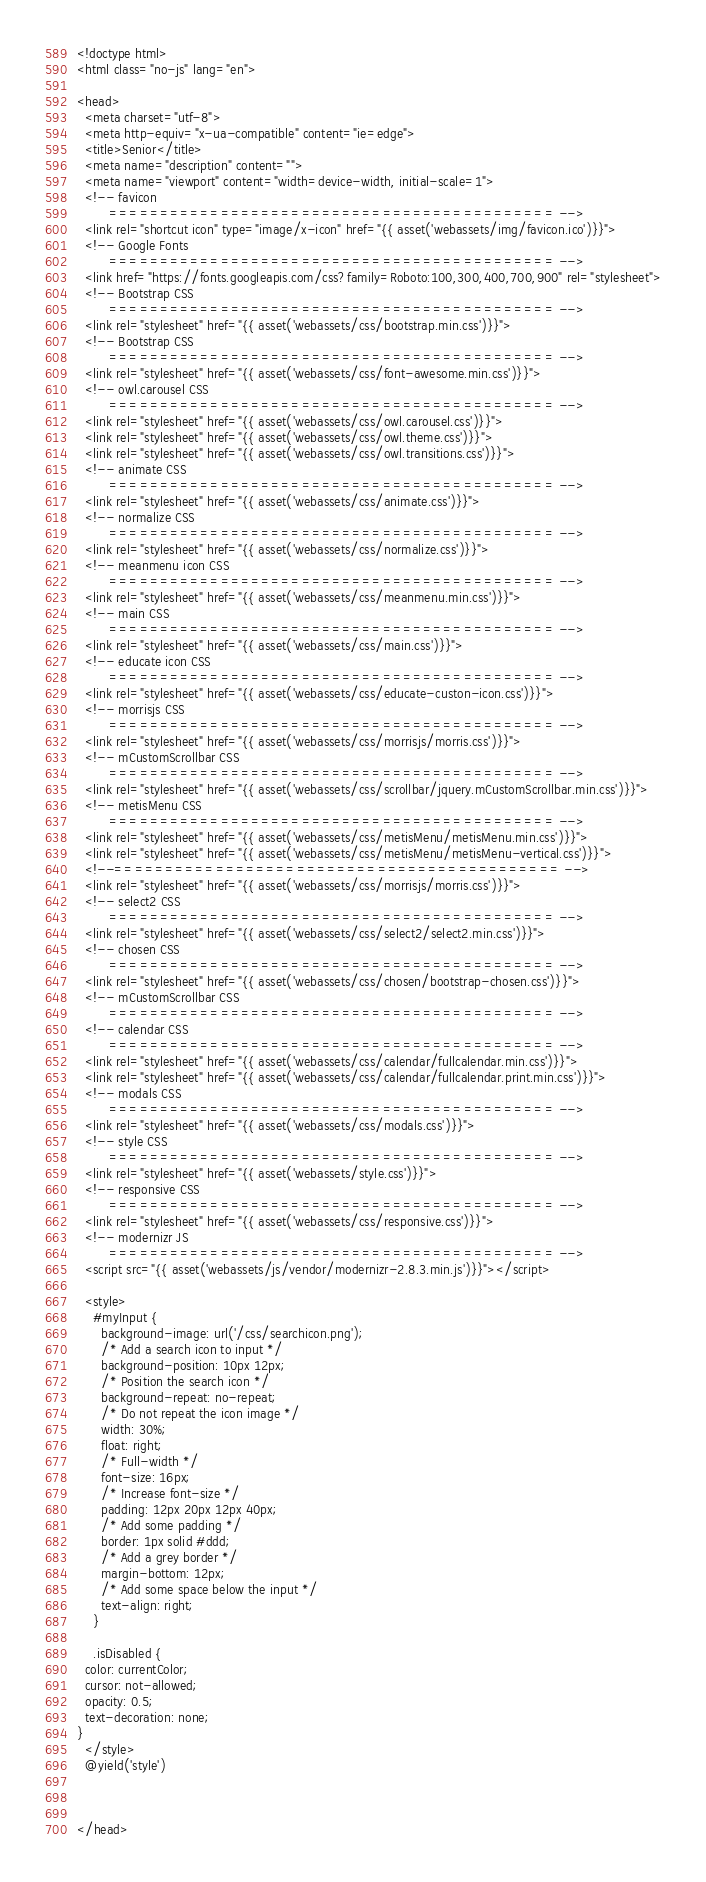Convert code to text. <code><loc_0><loc_0><loc_500><loc_500><_PHP_><!doctype html>
<html class="no-js" lang="en">

<head>
  <meta charset="utf-8">
  <meta http-equiv="x-ua-compatible" content="ie=edge">
  <title>Senior</title>
  <meta name="description" content="">
  <meta name="viewport" content="width=device-width, initial-scale=1">
  <!-- favicon
		============================================ -->
  <link rel="shortcut icon" type="image/x-icon" href="{{ asset('webassets/img/favicon.ico')}}">
  <!-- Google Fonts
		============================================ -->
  <link href="https://fonts.googleapis.com/css?family=Roboto:100,300,400,700,900" rel="stylesheet">
  <!-- Bootstrap CSS
		============================================ -->
  <link rel="stylesheet" href="{{ asset('webassets/css/bootstrap.min.css')}}">
  <!-- Bootstrap CSS
		============================================ -->
  <link rel="stylesheet" href="{{ asset('webassets/css/font-awesome.min.css')}}">
  <!-- owl.carousel CSS
		============================================ -->
  <link rel="stylesheet" href="{{ asset('webassets/css/owl.carousel.css')}}">
  <link rel="stylesheet" href="{{ asset('webassets/css/owl.theme.css')}}">
  <link rel="stylesheet" href="{{ asset('webassets/css/owl.transitions.css')}}">
  <!-- animate CSS
		============================================ -->
  <link rel="stylesheet" href="{{ asset('webassets/css/animate.css')}}">
  <!-- normalize CSS
		============================================ -->
  <link rel="stylesheet" href="{{ asset('webassets/css/normalize.css')}}">
  <!-- meanmenu icon CSS
		============================================ -->
  <link rel="stylesheet" href="{{ asset('webassets/css/meanmenu.min.css')}}">
  <!-- main CSS
		============================================ -->
  <link rel="stylesheet" href="{{ asset('webassets/css/main.css')}}">
  <!-- educate icon CSS
		============================================ -->
  <link rel="stylesheet" href="{{ asset('webassets/css/educate-custon-icon.css')}}">
  <!-- morrisjs CSS
		============================================ -->
  <link rel="stylesheet" href="{{ asset('webassets/css/morrisjs/morris.css')}}">
  <!-- mCustomScrollbar CSS
		============================================ -->
  <link rel="stylesheet" href="{{ asset('webassets/css/scrollbar/jquery.mCustomScrollbar.min.css')}}">
  <!-- metisMenu CSS
		============================================ -->
  <link rel="stylesheet" href="{{ asset('webassets/css/metisMenu/metisMenu.min.css')}}">
  <link rel="stylesheet" href="{{ asset('webassets/css/metisMenu/metisMenu-vertical.css')}}">
  <!--============================================ -->
  <link rel="stylesheet" href="{{ asset('webassets/css/morrisjs/morris.css')}}">
  <!-- select2 CSS
		============================================ -->
  <link rel="stylesheet" href="{{ asset('webassets/css/select2/select2.min.css')}}">
  <!-- chosen CSS
		============================================ -->
  <link rel="stylesheet" href="{{ asset('webassets/css/chosen/bootstrap-chosen.css')}}">
  <!-- mCustomScrollbar CSS
		============================================ -->
  <!-- calendar CSS
		============================================ -->
  <link rel="stylesheet" href="{{ asset('webassets/css/calendar/fullcalendar.min.css')}}">
  <link rel="stylesheet" href="{{ asset('webassets/css/calendar/fullcalendar.print.min.css')}}">
  <!-- modals CSS
		============================================ -->
  <link rel="stylesheet" href="{{ asset('webassets/css/modals.css')}}">
  <!-- style CSS
		============================================ -->
  <link rel="stylesheet" href="{{ asset('webassets/style.css')}}">
  <!-- responsive CSS
		============================================ -->
  <link rel="stylesheet" href="{{ asset('webassets/css/responsive.css')}}">
  <!-- modernizr JS
		============================================ -->
  <script src="{{ asset('webassets/js/vendor/modernizr-2.8.3.min.js')}}"></script>

  <style>
    #myInput {
      background-image: url('/css/searchicon.png');
      /* Add a search icon to input */
      background-position: 10px 12px;
      /* Position the search icon */
      background-repeat: no-repeat;
      /* Do not repeat the icon image */
      width: 30%;
      float: right;
      /* Full-width */
      font-size: 16px;
      /* Increase font-size */
      padding: 12px 20px 12px 40px;
      /* Add some padding */
      border: 1px solid #ddd;
      /* Add a grey border */
      margin-bottom: 12px;
      /* Add some space below the input */
      text-align: right;
    }

    .isDisabled {
  color: currentColor;
  cursor: not-allowed;
  opacity: 0.5;
  text-decoration: none;
}
  </style>
  @yield('style')



</head></code> 